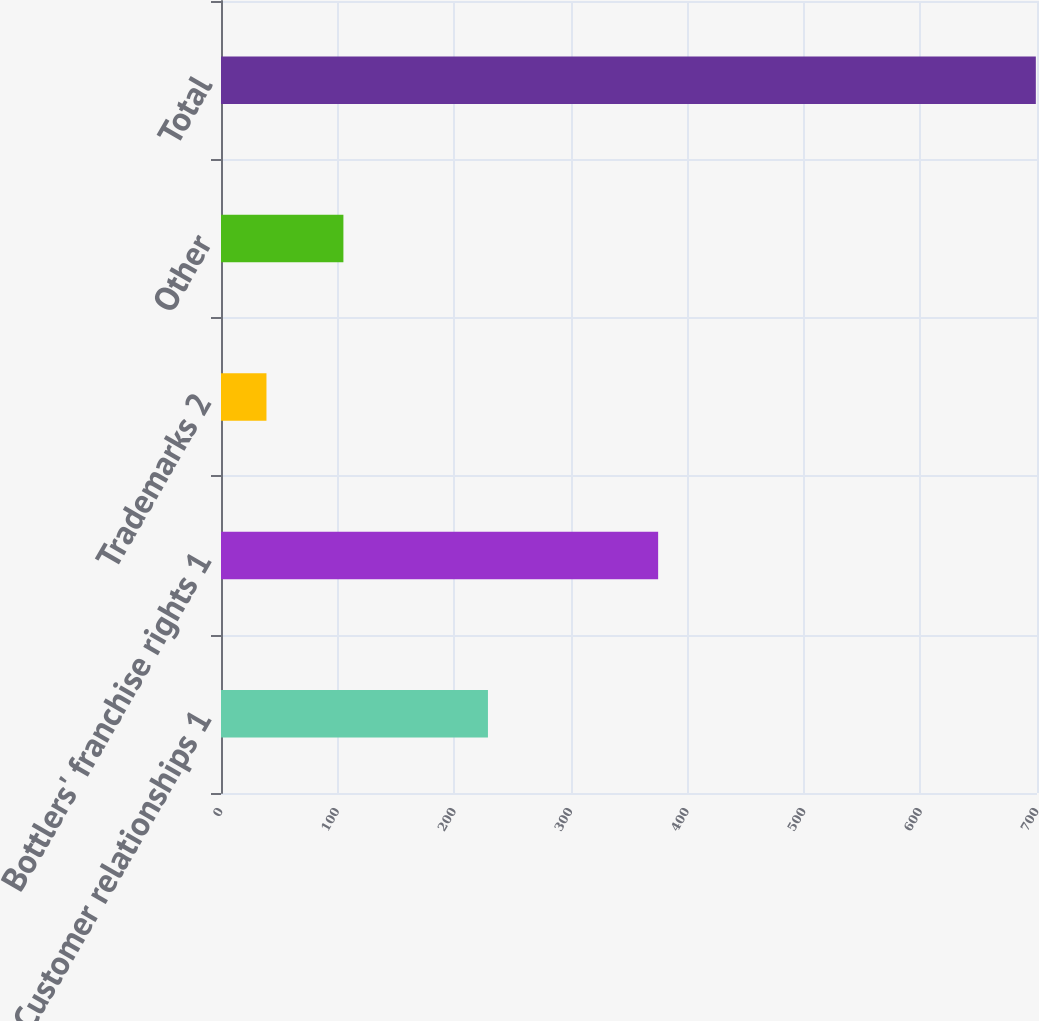Convert chart. <chart><loc_0><loc_0><loc_500><loc_500><bar_chart><fcel>Customer relationships 1<fcel>Bottlers' franchise rights 1<fcel>Trademarks 2<fcel>Other<fcel>Total<nl><fcel>229<fcel>375<fcel>39<fcel>105<fcel>699<nl></chart> 